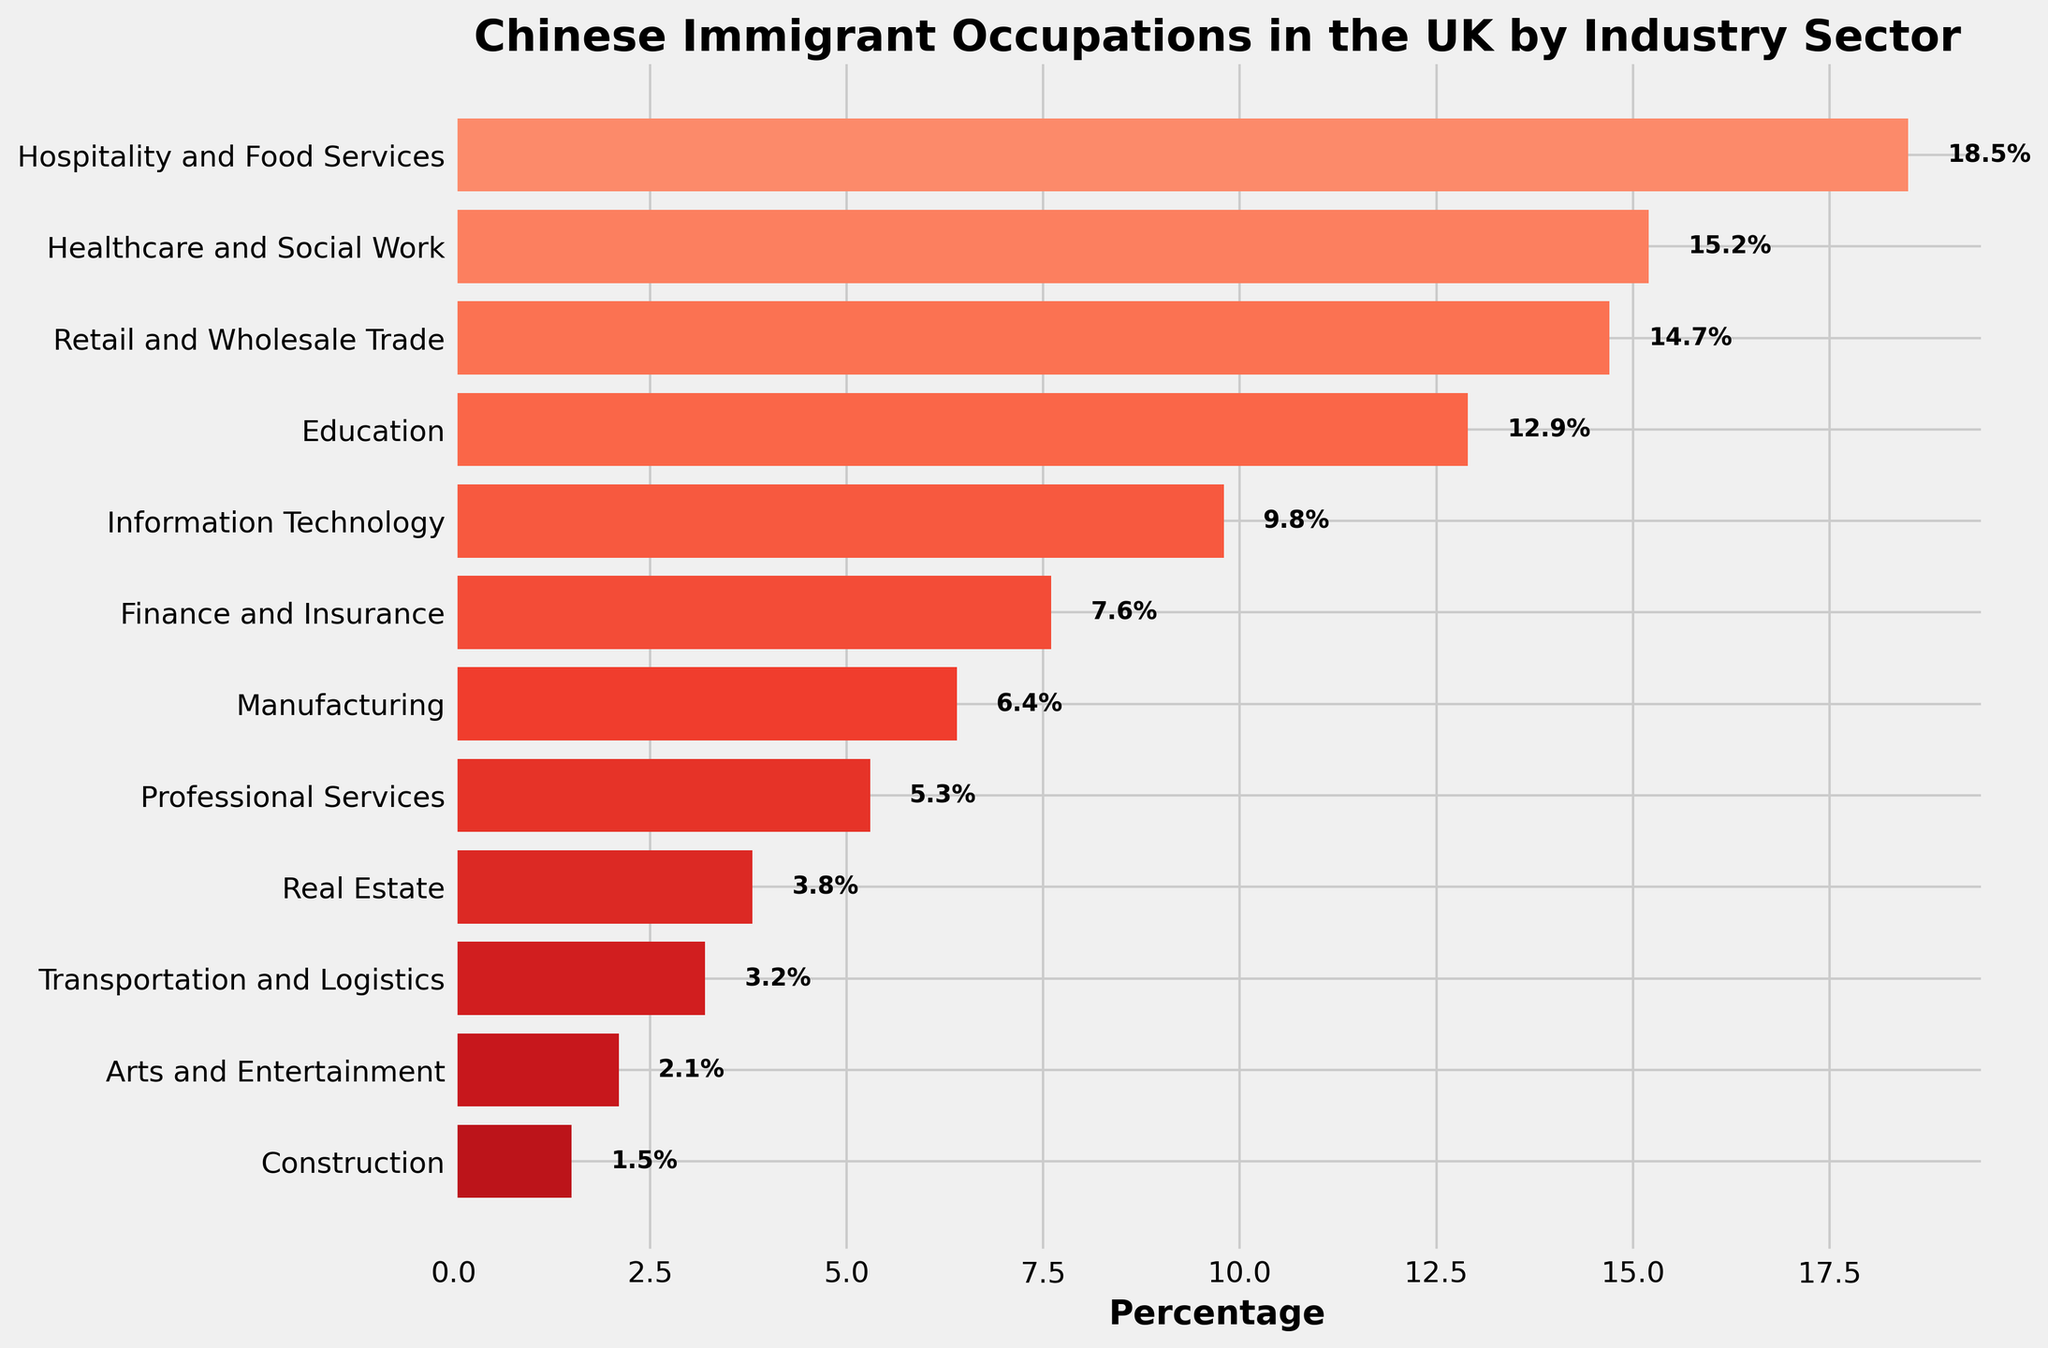What's the top industry sector for Chinese immigrants in the UK? According to the bar chart, the industry sector with the highest percentage is Hospitality and Food Services at 18.5%.
Answer: Hospitality and Food Services Which industry sector has the least percentage? The bar chart shows that the Construction industry has the lowest percentage at 1.5%.
Answer: Construction How does the percentage of Healthcare and Social Work compare to Manufacturing? The percentage for Healthcare and Social Work is 15.2%, while for Manufacturing it is 6.4%. Therefore, Healthcare and Social Work is higher.
Answer: Healthcare and Social Work is higher What is the combined percentage of Information Technology and Finance and Insurance? Information Technology has 9.8% and Finance and Insurance has 7.6%. Summing these two percentages gives 9.8 + 7.6 = 17.4%.
Answer: 17.4% Which sectors have a percentage greater than 10%? The sectors with percentages greater than 10% are: Hospitality and Food Services (18.5%), Healthcare and Social Work (15.2%), Retail and Wholesale Trade (14.7%), and Education (12.9%).
Answer: Hospitality and Food Services, Healthcare and Social Work, Retail and Wholesale Trade, Education What is the difference in percentage between Real Estate and Professional Services? Real Estate has a percentage of 3.8% and Professional Services has 5.3%. The difference is 5.3 - 3.8 = 1.5%.
Answer: 1.5% What is the sum of the percentages of the three lowest sectors? The three lowest sectors are Construction (1.5%), Arts and Entertainment (2.1%), and Transportation and Logistics (3.2%). Adding these gives 1.5 + 2.1 + 3.2 = 6.8%.
Answer: 6.8% Are there more Chinese immigrants in Education or Retail and Wholesale Trade? The percentage for Education is 12.9%, while for Retail and Wholesale Trade it is 14.7%. Therefore, there are more Chinese immigrants in Retail and Wholesale Trade.
Answer: Retail and Wholesale Trade What is the average percentage for the sectors with less than 10%? The sectors with less than 10% and their percentages are: Information Technology (9.8%), Finance and Insurance (7.6%), Manufacturing (6.4%), Professional Services (5.3%), Real Estate (3.8%), Transportation and Logistics (3.2%), Arts and Entertainment (2.1%), and Construction (1.5%). Their sum is 9.8 + 7.6 + 6.4 + 5.3 + 3.8 + 3.2 + 2.1 + 1.5 = 39.7. There are 8 sectors, so the average is 39.7 / 8 = 4.96%.
Answer: 4.96% 